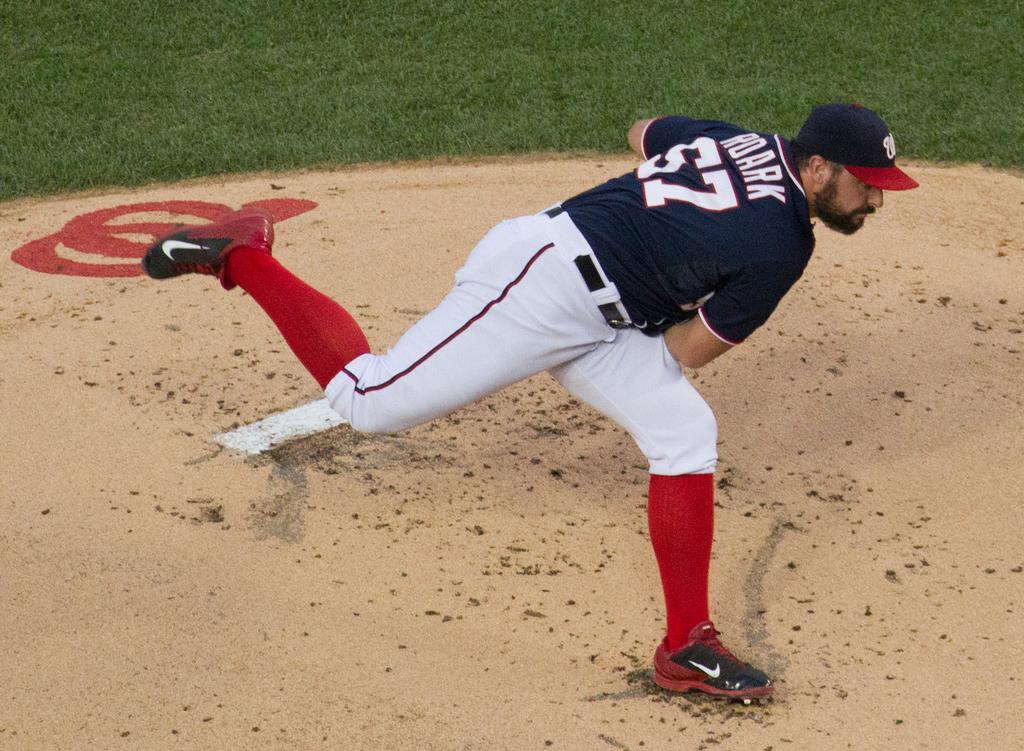<image>
Summarize the visual content of the image. Baseball player wearing number 57 throwing a baseball. 